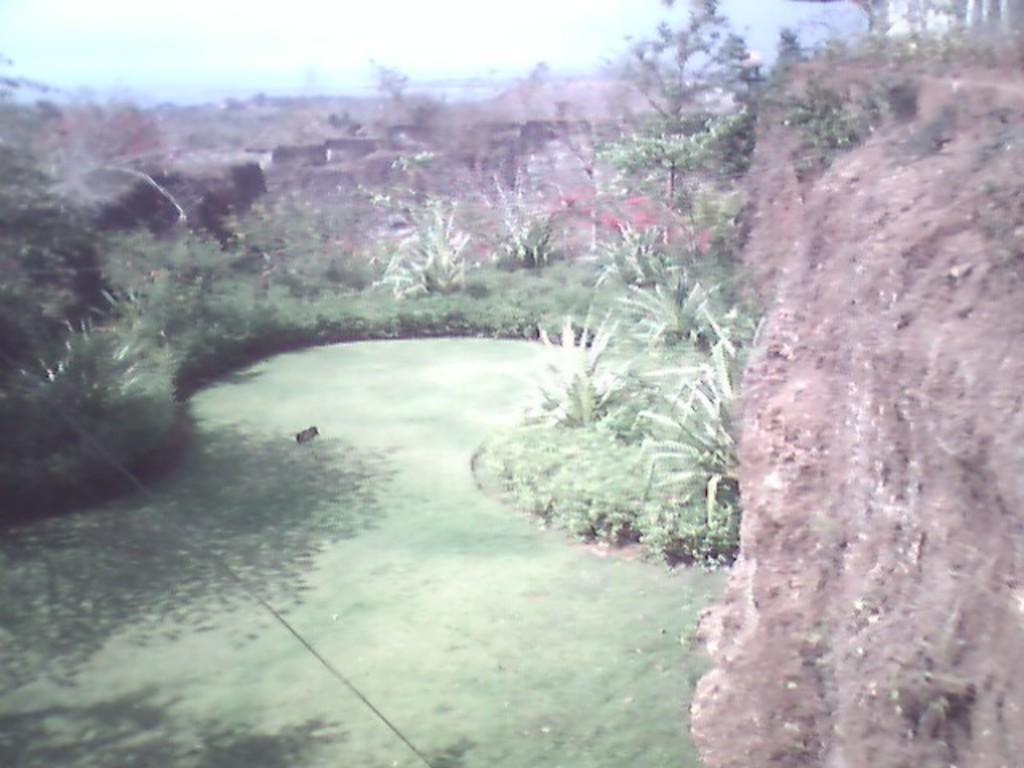Describe this image in one or two sentences. In this image at the bottom there is some grass and some plants, in the background there are some trees. On the right side there is a mountain. 